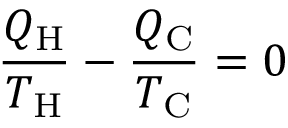<formula> <loc_0><loc_0><loc_500><loc_500>{ \frac { Q _ { H } } { T _ { H } } } - { \frac { Q _ { C } } { T _ { C } } } = 0</formula> 